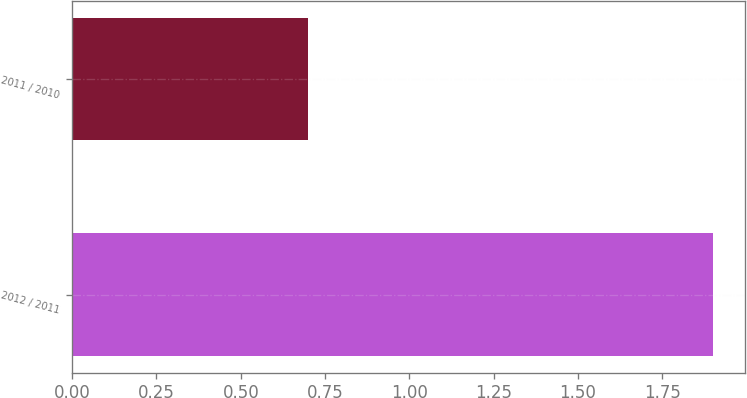Convert chart to OTSL. <chart><loc_0><loc_0><loc_500><loc_500><bar_chart><fcel>2012 / 2011<fcel>2011 / 2010<nl><fcel>1.9<fcel>0.7<nl></chart> 